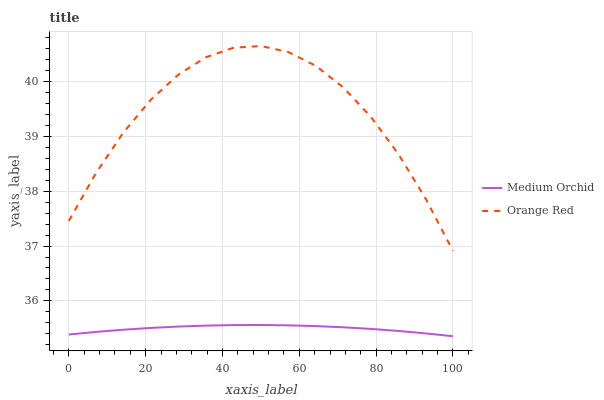Does Medium Orchid have the minimum area under the curve?
Answer yes or no. Yes. Does Orange Red have the maximum area under the curve?
Answer yes or no. Yes. Does Orange Red have the minimum area under the curve?
Answer yes or no. No. Is Medium Orchid the smoothest?
Answer yes or no. Yes. Is Orange Red the roughest?
Answer yes or no. Yes. Is Orange Red the smoothest?
Answer yes or no. No. Does Medium Orchid have the lowest value?
Answer yes or no. Yes. Does Orange Red have the lowest value?
Answer yes or no. No. Does Orange Red have the highest value?
Answer yes or no. Yes. Is Medium Orchid less than Orange Red?
Answer yes or no. Yes. Is Orange Red greater than Medium Orchid?
Answer yes or no. Yes. Does Medium Orchid intersect Orange Red?
Answer yes or no. No. 